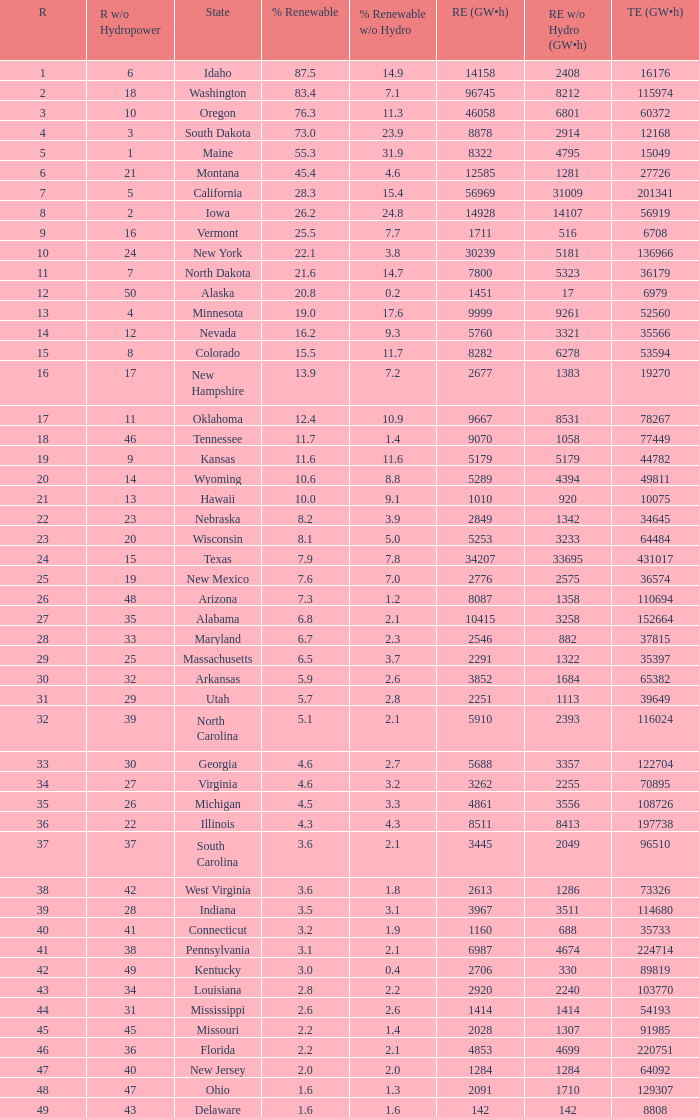Which states have renewable electricity equal to 9667 (gw×h)? Oklahoma. 